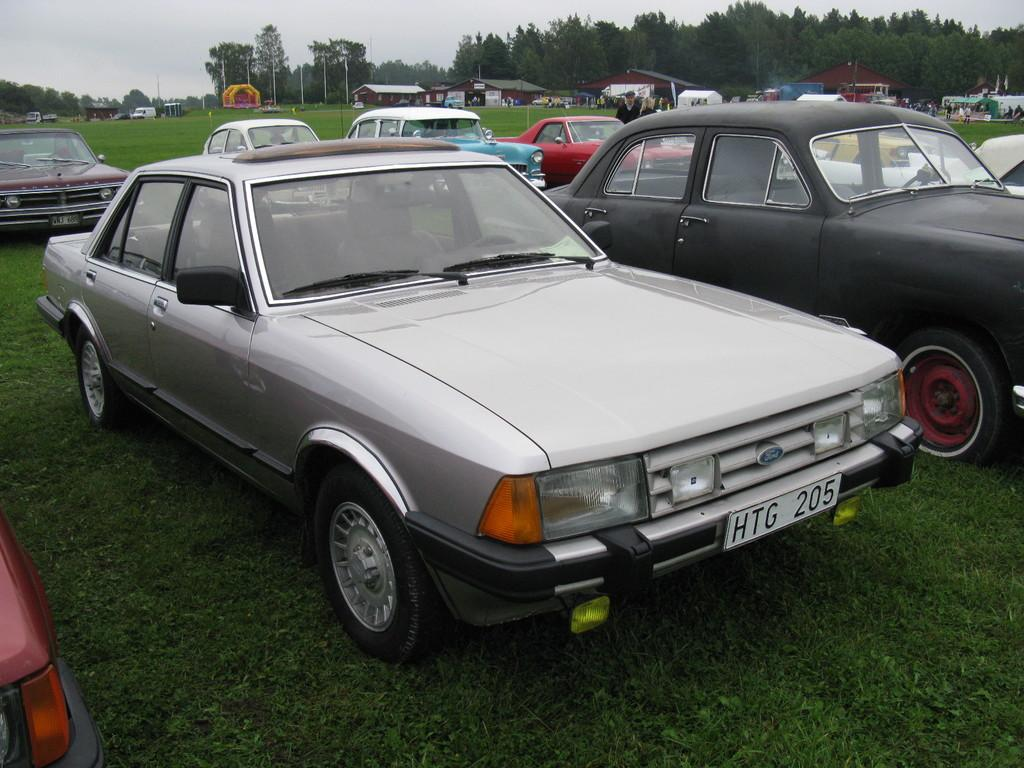What types of objects are present in the image? There are vehicles and people on the ground in the image. What can be seen in the background of the image? There are houses, electric poles, trees, and the sky visible in the background of the image. What type of cream can be seen dripping from the electric poles in the image? There is no cream present in the image, nor is it dripping from the electric poles. 